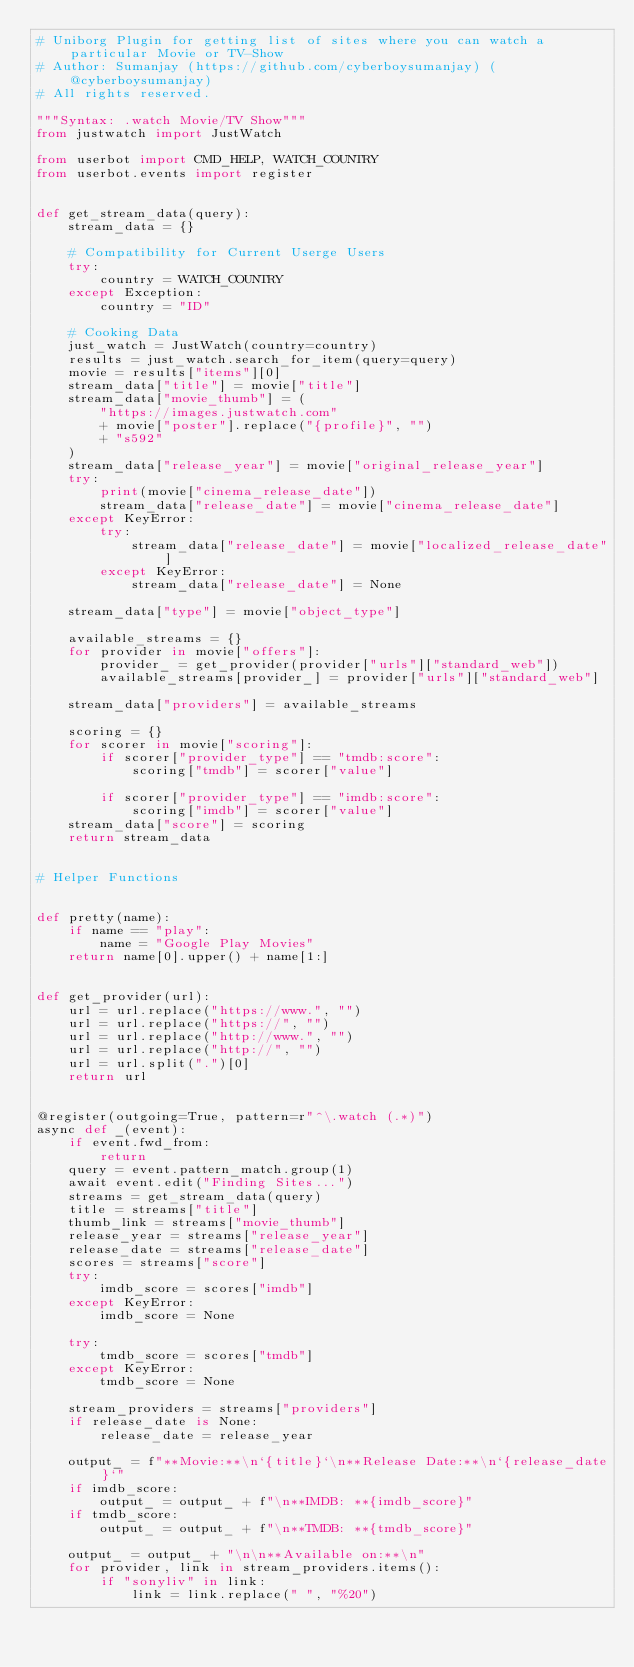Convert code to text. <code><loc_0><loc_0><loc_500><loc_500><_Python_># Uniborg Plugin for getting list of sites where you can watch a particular Movie or TV-Show
# Author: Sumanjay (https://github.com/cyberboysumanjay) (@cyberboysumanjay)
# All rights reserved.

"""Syntax: .watch Movie/TV Show"""
from justwatch import JustWatch

from userbot import CMD_HELP, WATCH_COUNTRY
from userbot.events import register


def get_stream_data(query):
    stream_data = {}

    # Compatibility for Current Userge Users
    try:
        country = WATCH_COUNTRY
    except Exception:
        country = "ID"

    # Cooking Data
    just_watch = JustWatch(country=country)
    results = just_watch.search_for_item(query=query)
    movie = results["items"][0]
    stream_data["title"] = movie["title"]
    stream_data["movie_thumb"] = (
        "https://images.justwatch.com"
        + movie["poster"].replace("{profile}", "")
        + "s592"
    )
    stream_data["release_year"] = movie["original_release_year"]
    try:
        print(movie["cinema_release_date"])
        stream_data["release_date"] = movie["cinema_release_date"]
    except KeyError:
        try:
            stream_data["release_date"] = movie["localized_release_date"]
        except KeyError:
            stream_data["release_date"] = None

    stream_data["type"] = movie["object_type"]

    available_streams = {}
    for provider in movie["offers"]:
        provider_ = get_provider(provider["urls"]["standard_web"])
        available_streams[provider_] = provider["urls"]["standard_web"]

    stream_data["providers"] = available_streams

    scoring = {}
    for scorer in movie["scoring"]:
        if scorer["provider_type"] == "tmdb:score":
            scoring["tmdb"] = scorer["value"]

        if scorer["provider_type"] == "imdb:score":
            scoring["imdb"] = scorer["value"]
    stream_data["score"] = scoring
    return stream_data


# Helper Functions


def pretty(name):
    if name == "play":
        name = "Google Play Movies"
    return name[0].upper() + name[1:]


def get_provider(url):
    url = url.replace("https://www.", "")
    url = url.replace("https://", "")
    url = url.replace("http://www.", "")
    url = url.replace("http://", "")
    url = url.split(".")[0]
    return url


@register(outgoing=True, pattern=r"^\.watch (.*)")
async def _(event):
    if event.fwd_from:
        return
    query = event.pattern_match.group(1)
    await event.edit("Finding Sites...")
    streams = get_stream_data(query)
    title = streams["title"]
    thumb_link = streams["movie_thumb"]
    release_year = streams["release_year"]
    release_date = streams["release_date"]
    scores = streams["score"]
    try:
        imdb_score = scores["imdb"]
    except KeyError:
        imdb_score = None

    try:
        tmdb_score = scores["tmdb"]
    except KeyError:
        tmdb_score = None

    stream_providers = streams["providers"]
    if release_date is None:
        release_date = release_year

    output_ = f"**Movie:**\n`{title}`\n**Release Date:**\n`{release_date}`"
    if imdb_score:
        output_ = output_ + f"\n**IMDB: **{imdb_score}"
    if tmdb_score:
        output_ = output_ + f"\n**TMDB: **{tmdb_score}"

    output_ = output_ + "\n\n**Available on:**\n"
    for provider, link in stream_providers.items():
        if "sonyliv" in link:
            link = link.replace(" ", "%20")</code> 